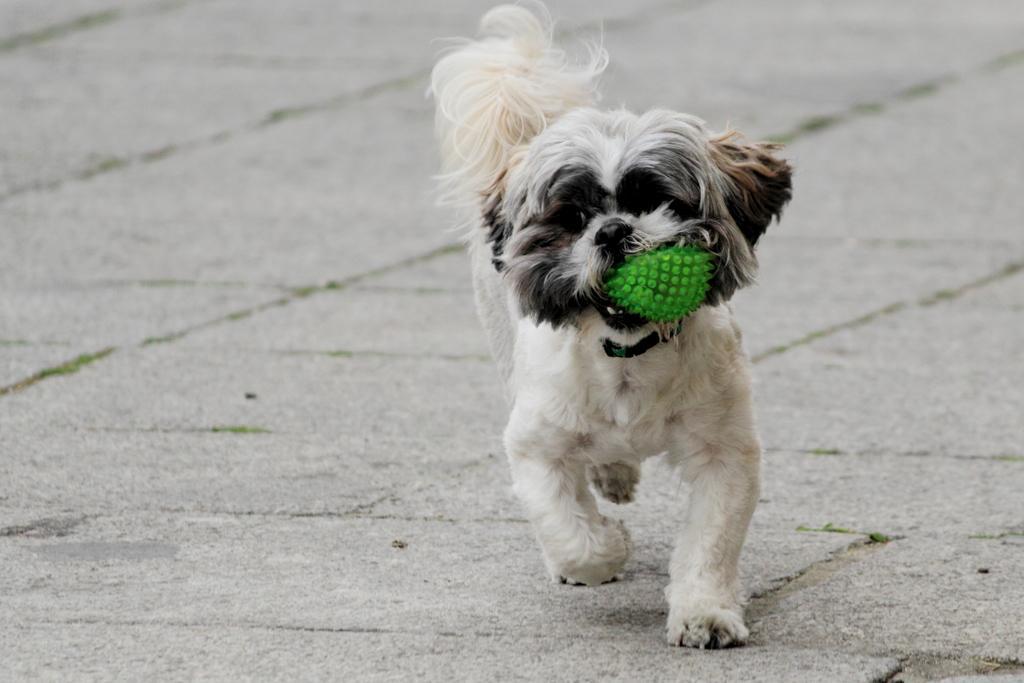In one or two sentences, can you explain what this image depicts? In this image in the front there is a dog running on the ground. 